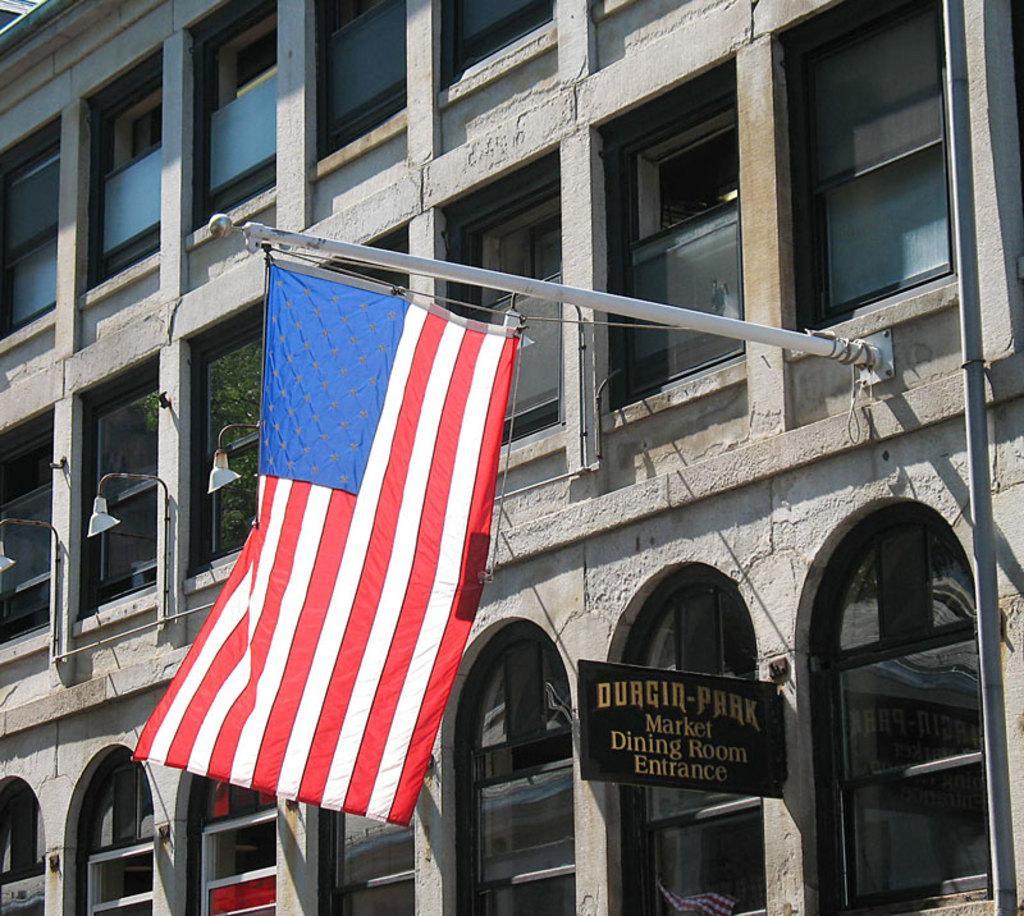Can you describe this image briefly? In this image I can see a building, number of windows, few lights, few poles, a board, a flag and here on this board I can see something is written. 